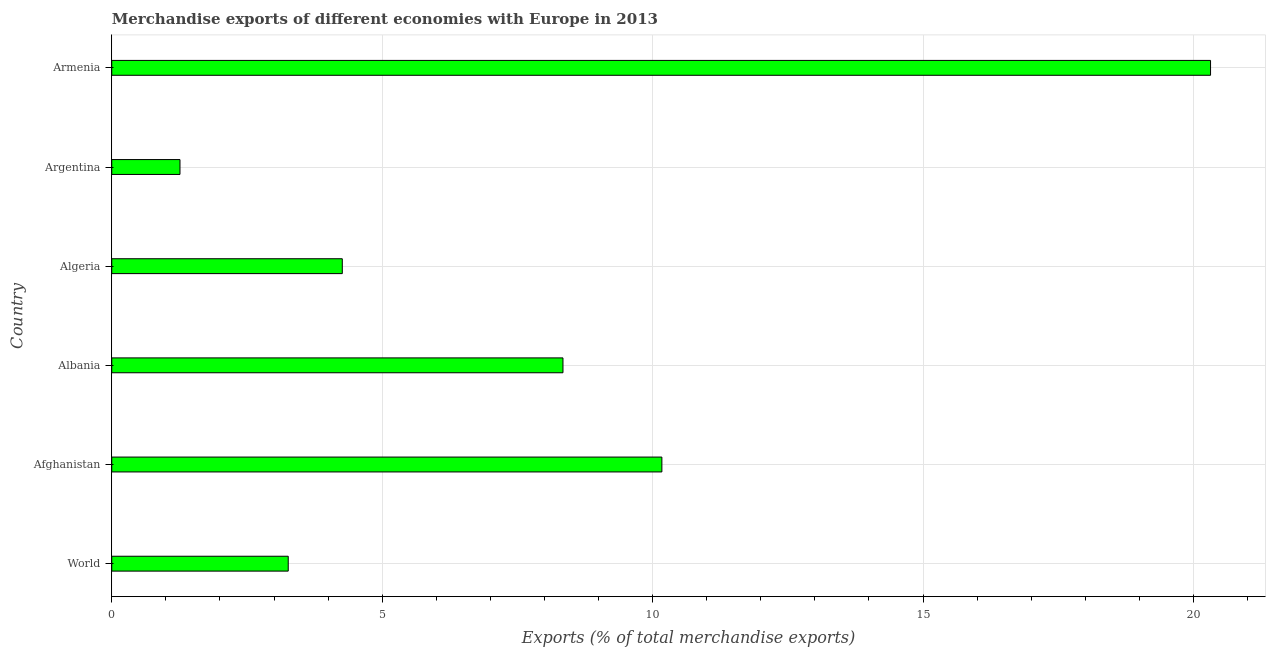Does the graph contain any zero values?
Offer a very short reply. No. What is the title of the graph?
Offer a very short reply. Merchandise exports of different economies with Europe in 2013. What is the label or title of the X-axis?
Your response must be concise. Exports (% of total merchandise exports). What is the merchandise exports in Albania?
Keep it short and to the point. 8.34. Across all countries, what is the maximum merchandise exports?
Provide a short and direct response. 20.31. Across all countries, what is the minimum merchandise exports?
Provide a succinct answer. 1.26. In which country was the merchandise exports maximum?
Offer a very short reply. Armenia. In which country was the merchandise exports minimum?
Ensure brevity in your answer.  Argentina. What is the sum of the merchandise exports?
Provide a succinct answer. 47.61. What is the difference between the merchandise exports in Afghanistan and World?
Offer a very short reply. 6.91. What is the average merchandise exports per country?
Provide a short and direct response. 7.94. What is the median merchandise exports?
Provide a succinct answer. 6.3. In how many countries, is the merchandise exports greater than 9 %?
Provide a succinct answer. 2. What is the ratio of the merchandise exports in Albania to that in Argentina?
Provide a succinct answer. 6.61. Is the difference between the merchandise exports in Afghanistan and Argentina greater than the difference between any two countries?
Your answer should be very brief. No. What is the difference between the highest and the second highest merchandise exports?
Make the answer very short. 10.14. What is the difference between the highest and the lowest merchandise exports?
Your answer should be very brief. 19.05. In how many countries, is the merchandise exports greater than the average merchandise exports taken over all countries?
Your answer should be compact. 3. Are the values on the major ticks of X-axis written in scientific E-notation?
Ensure brevity in your answer.  No. What is the Exports (% of total merchandise exports) in World?
Offer a terse response. 3.26. What is the Exports (% of total merchandise exports) in Afghanistan?
Your response must be concise. 10.17. What is the Exports (% of total merchandise exports) in Albania?
Provide a short and direct response. 8.34. What is the Exports (% of total merchandise exports) in Algeria?
Ensure brevity in your answer.  4.26. What is the Exports (% of total merchandise exports) in Argentina?
Ensure brevity in your answer.  1.26. What is the Exports (% of total merchandise exports) in Armenia?
Give a very brief answer. 20.31. What is the difference between the Exports (% of total merchandise exports) in World and Afghanistan?
Ensure brevity in your answer.  -6.91. What is the difference between the Exports (% of total merchandise exports) in World and Albania?
Your answer should be very brief. -5.08. What is the difference between the Exports (% of total merchandise exports) in World and Algeria?
Provide a succinct answer. -1. What is the difference between the Exports (% of total merchandise exports) in World and Argentina?
Offer a very short reply. 2. What is the difference between the Exports (% of total merchandise exports) in World and Armenia?
Offer a terse response. -17.05. What is the difference between the Exports (% of total merchandise exports) in Afghanistan and Albania?
Your answer should be very brief. 1.83. What is the difference between the Exports (% of total merchandise exports) in Afghanistan and Algeria?
Make the answer very short. 5.91. What is the difference between the Exports (% of total merchandise exports) in Afghanistan and Argentina?
Keep it short and to the point. 8.91. What is the difference between the Exports (% of total merchandise exports) in Afghanistan and Armenia?
Provide a short and direct response. -10.14. What is the difference between the Exports (% of total merchandise exports) in Albania and Algeria?
Keep it short and to the point. 4.08. What is the difference between the Exports (% of total merchandise exports) in Albania and Argentina?
Provide a succinct answer. 7.08. What is the difference between the Exports (% of total merchandise exports) in Albania and Armenia?
Your answer should be very brief. -11.97. What is the difference between the Exports (% of total merchandise exports) in Algeria and Argentina?
Your response must be concise. 3. What is the difference between the Exports (% of total merchandise exports) in Algeria and Armenia?
Ensure brevity in your answer.  -16.05. What is the difference between the Exports (% of total merchandise exports) in Argentina and Armenia?
Provide a short and direct response. -19.05. What is the ratio of the Exports (% of total merchandise exports) in World to that in Afghanistan?
Provide a succinct answer. 0.32. What is the ratio of the Exports (% of total merchandise exports) in World to that in Albania?
Your answer should be very brief. 0.39. What is the ratio of the Exports (% of total merchandise exports) in World to that in Algeria?
Your answer should be compact. 0.77. What is the ratio of the Exports (% of total merchandise exports) in World to that in Argentina?
Offer a terse response. 2.59. What is the ratio of the Exports (% of total merchandise exports) in World to that in Armenia?
Give a very brief answer. 0.16. What is the ratio of the Exports (% of total merchandise exports) in Afghanistan to that in Albania?
Give a very brief answer. 1.22. What is the ratio of the Exports (% of total merchandise exports) in Afghanistan to that in Algeria?
Keep it short and to the point. 2.39. What is the ratio of the Exports (% of total merchandise exports) in Afghanistan to that in Argentina?
Your answer should be very brief. 8.06. What is the ratio of the Exports (% of total merchandise exports) in Afghanistan to that in Armenia?
Offer a terse response. 0.5. What is the ratio of the Exports (% of total merchandise exports) in Albania to that in Algeria?
Offer a very short reply. 1.96. What is the ratio of the Exports (% of total merchandise exports) in Albania to that in Argentina?
Ensure brevity in your answer.  6.61. What is the ratio of the Exports (% of total merchandise exports) in Albania to that in Armenia?
Your answer should be compact. 0.41. What is the ratio of the Exports (% of total merchandise exports) in Algeria to that in Argentina?
Give a very brief answer. 3.38. What is the ratio of the Exports (% of total merchandise exports) in Algeria to that in Armenia?
Offer a very short reply. 0.21. What is the ratio of the Exports (% of total merchandise exports) in Argentina to that in Armenia?
Provide a short and direct response. 0.06. 